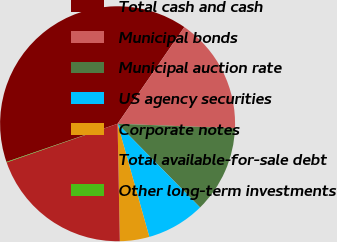Convert chart. <chart><loc_0><loc_0><loc_500><loc_500><pie_chart><fcel>Total cash and cash<fcel>Municipal bonds<fcel>Municipal auction rate<fcel>US agency securities<fcel>Corporate notes<fcel>Total available-for-sale debt<fcel>Other long-term investments<nl><fcel>39.88%<fcel>15.99%<fcel>12.01%<fcel>8.03%<fcel>4.05%<fcel>19.97%<fcel>0.07%<nl></chart> 